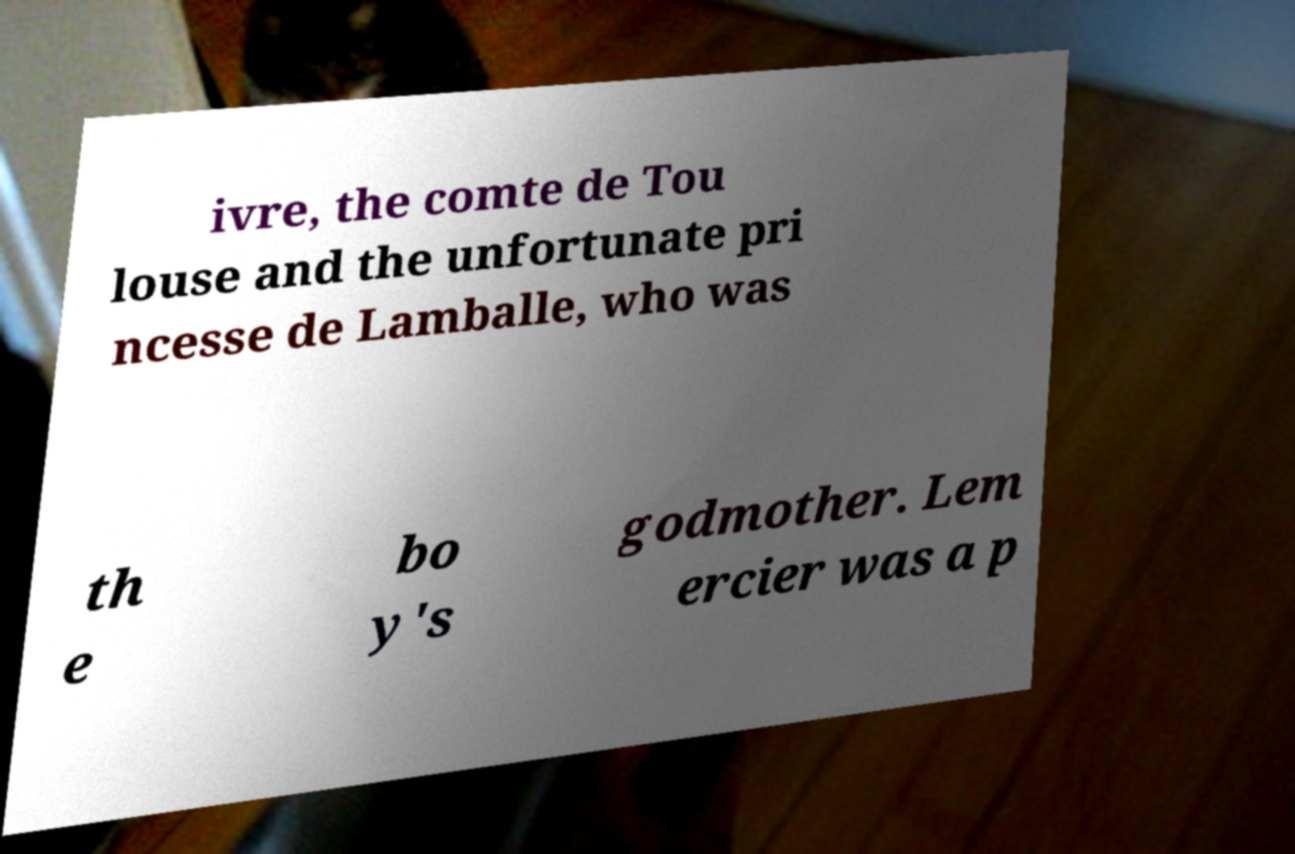For documentation purposes, I need the text within this image transcribed. Could you provide that? ivre, the comte de Tou louse and the unfortunate pri ncesse de Lamballe, who was th e bo y's godmother. Lem ercier was a p 